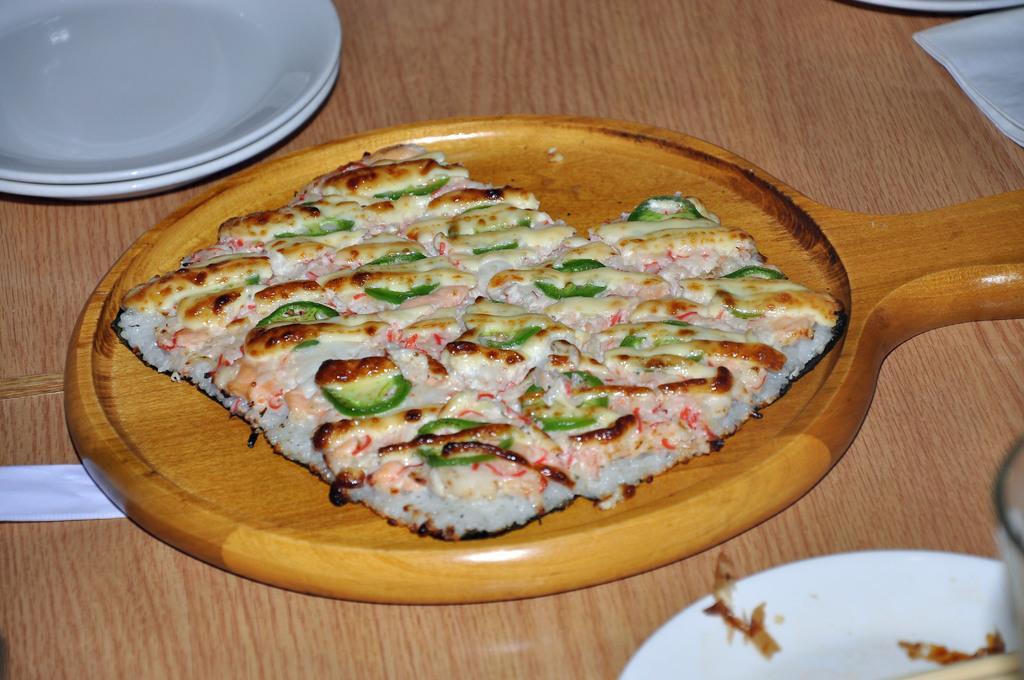Please provide a concise description of this image. In the center of this picture we can see a wooden platter containing some food item which seems to be the pizza and we can see the plates and some other items are placed on the top of the wooden table. 